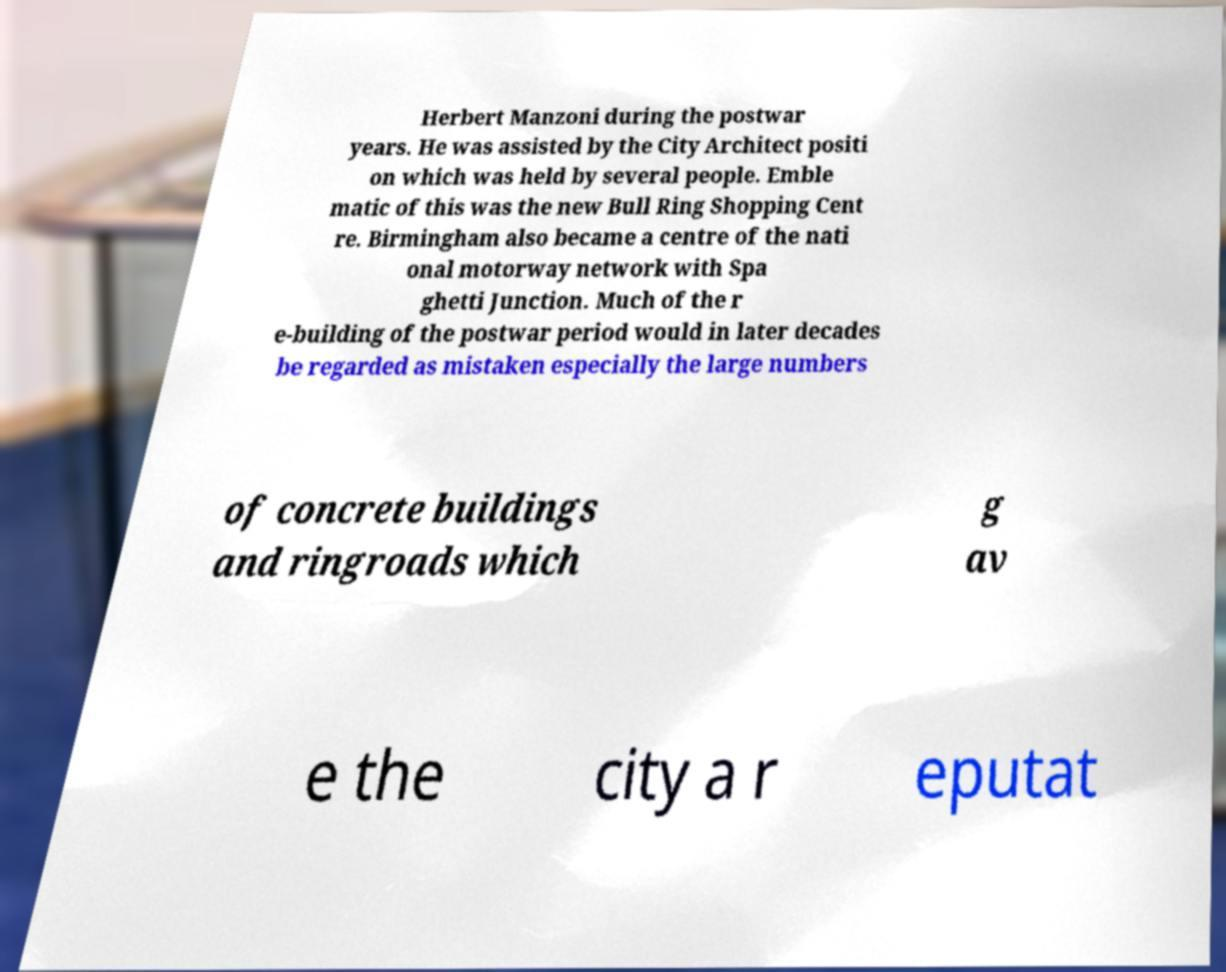Please identify and transcribe the text found in this image. Herbert Manzoni during the postwar years. He was assisted by the City Architect positi on which was held by several people. Emble matic of this was the new Bull Ring Shopping Cent re. Birmingham also became a centre of the nati onal motorway network with Spa ghetti Junction. Much of the r e-building of the postwar period would in later decades be regarded as mistaken especially the large numbers of concrete buildings and ringroads which g av e the city a r eputat 